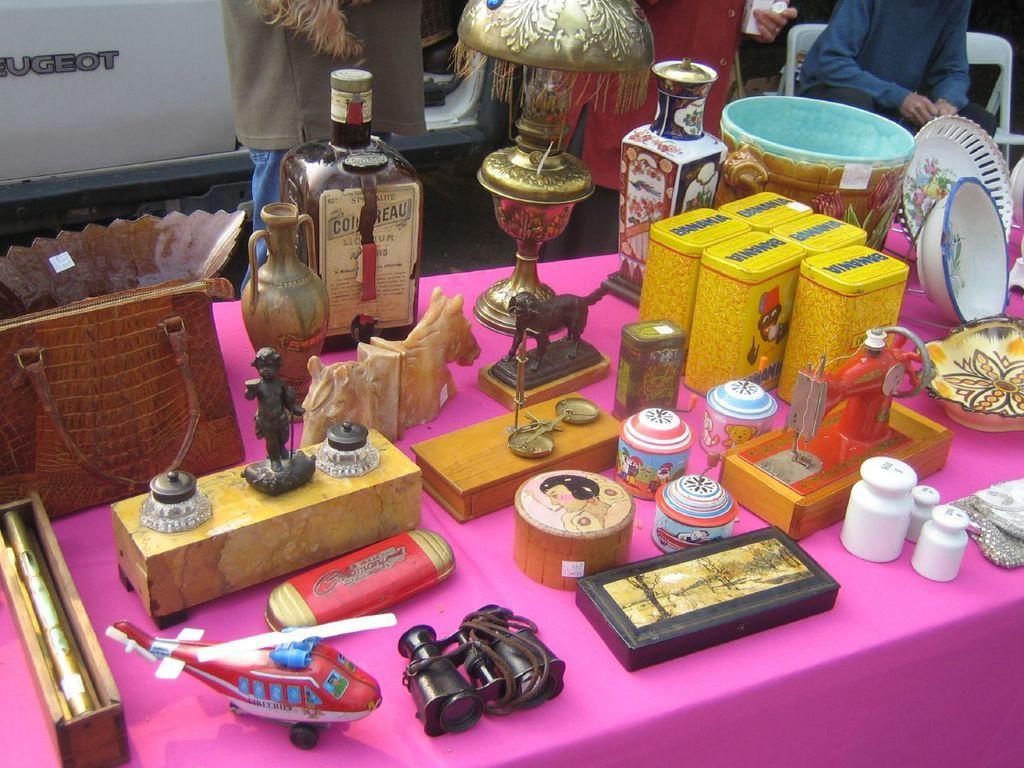In one or two sentences, can you explain what this image depicts? In this image we can see group of toys like helicopter, binoculars,sewing machine ,some containers and a table lamp and couple of bottles are placed on the table. In the background we can see group of people standing. One person wearing blue shirt is sitting on a chair and a vehicle parked on the ground. 